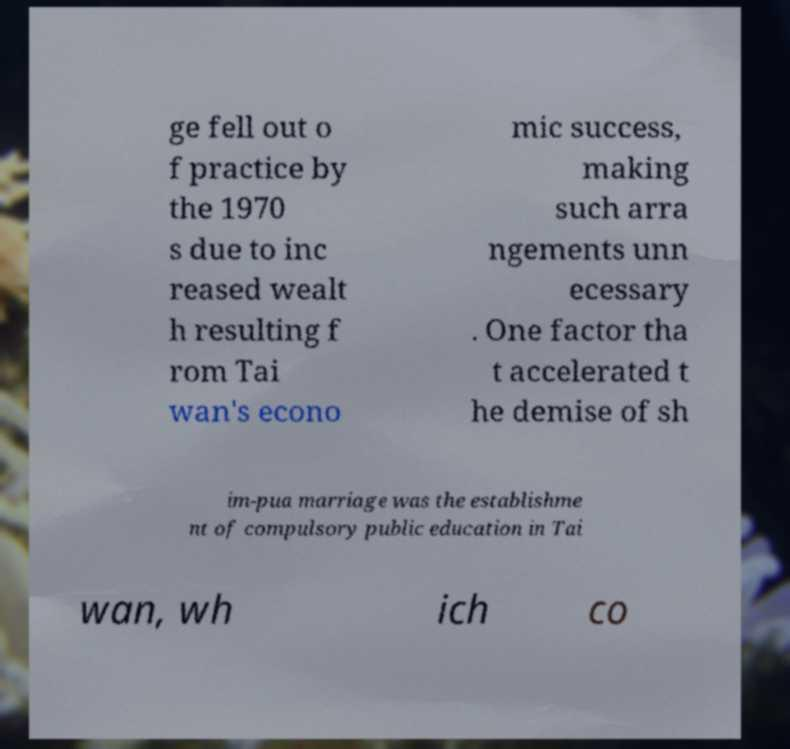Could you extract and type out the text from this image? ge fell out o f practice by the 1970 s due to inc reased wealt h resulting f rom Tai wan's econo mic success, making such arra ngements unn ecessary . One factor tha t accelerated t he demise of sh im-pua marriage was the establishme nt of compulsory public education in Tai wan, wh ich co 